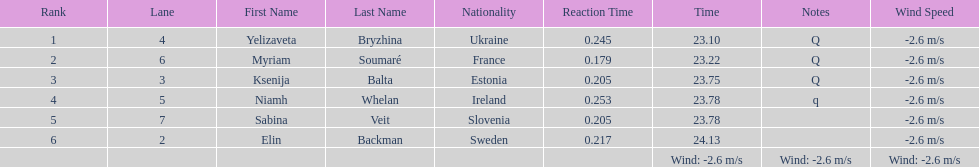Are any of the lanes in consecutive order? No. 